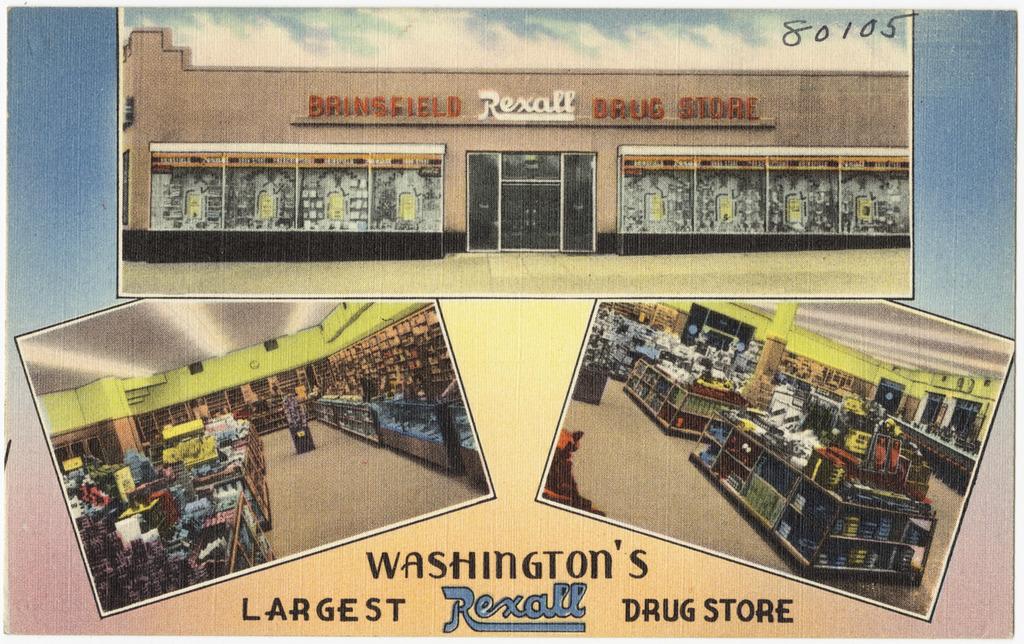What is the name of the store?
Provide a short and direct response. Rexall. Where is this drug store?
Ensure brevity in your answer.  Washington. 